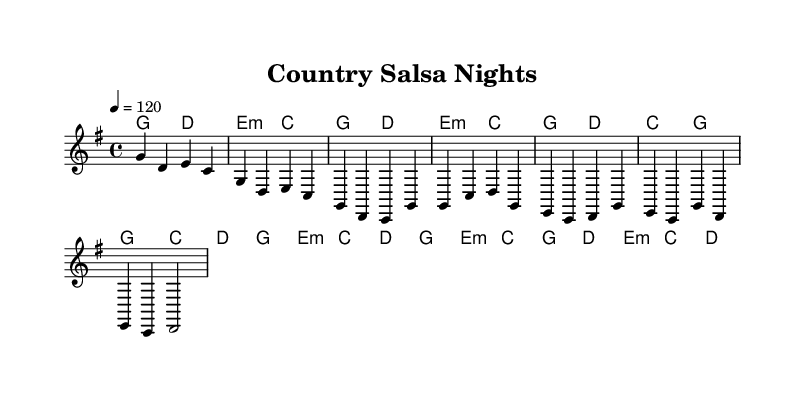What is the key signature of this music? The key signature is G major, which has one sharp (F#). This can be identified by looking at the beginning of the staff where the sharps are indicated.
Answer: G major What is the time signature of this music? The time signature is 4/4, which means there are four beats per measure and the quarter note receives one beat. This is visible at the beginning of the piece, right after the key signature.
Answer: 4/4 What is the tempo of this piece? The tempo marking is 120 beats per minute, indicated by the tempo text "4 = 120" at the beginning. This indicates the number of quarter note beats in one minute.
Answer: 120 How many measures are in the melody? The melody contains a total of 16 measures, as counted from the beginning to the end. Each group of notes separated by vertical lines (bar lines) represents a measure.
Answer: 16 What chords are used in the chorus section? The chords used in the chorus are G, C, D, and E minor. By looking at the chord symbols above the melody in the corresponding section, you can list the chords present in that specific part.
Answer: G, C, D, E minor What is the rhythmic structure of the bridge? The rhythmic structure of the bridge primarily uses quarter notes and half notes with a steady feel. The bridge prominently features the chords alternating with longer notes, reflective of the salsa rhythm's characteristic syncopation.
Answer: Quarter and half notes What blend of genres does this music represent? This music represents a blend of country and salsa, as indicated by the combination of lyrical themes and rhythmic styles from both genres. The Latin flavor is added through the use of salsa rhythms with country melodies.
Answer: Country and salsa 